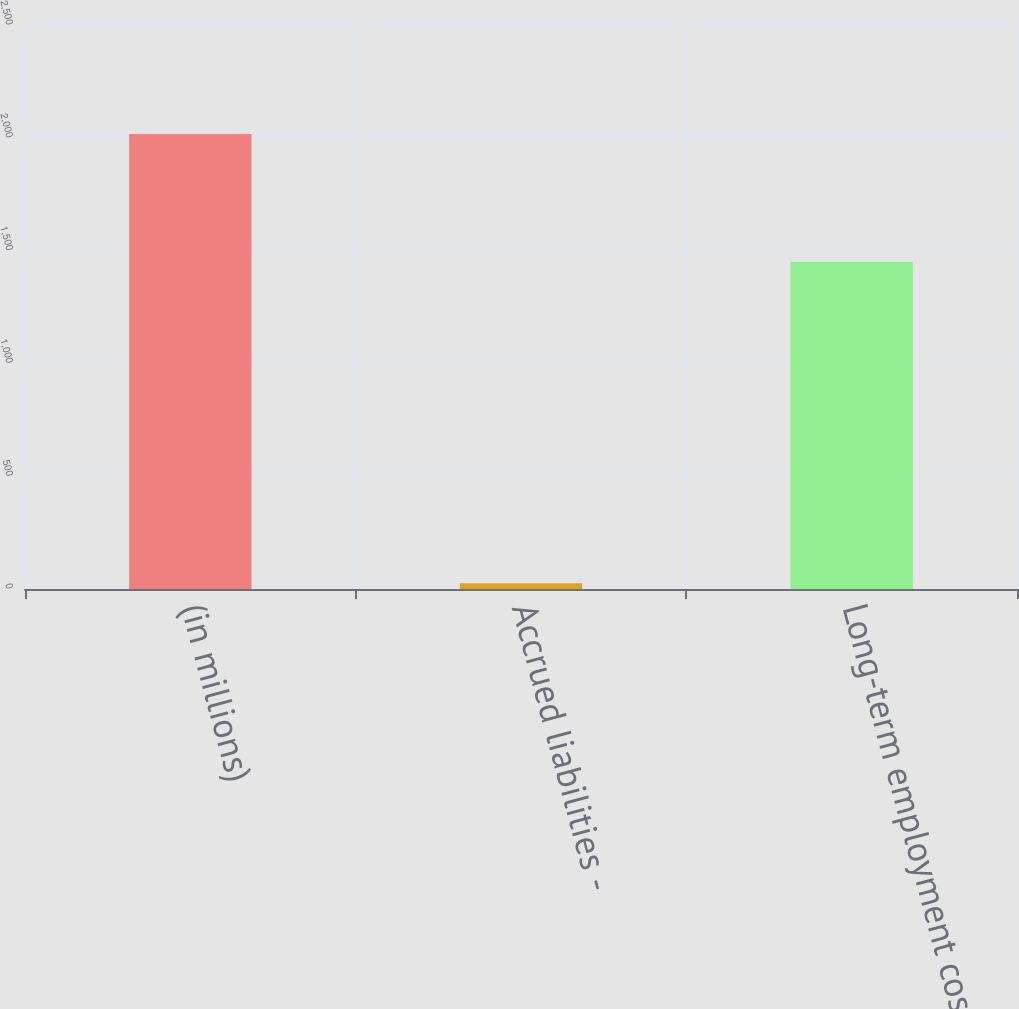<chart> <loc_0><loc_0><loc_500><loc_500><bar_chart><fcel>(in millions)<fcel>Accrued liabilities -<fcel>Long-term employment costs<nl><fcel>2017<fcel>26<fcel>1451<nl></chart> 